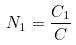Convert formula to latex. <formula><loc_0><loc_0><loc_500><loc_500>N _ { 1 } = \frac { C _ { 1 } } { C }</formula> 